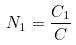Convert formula to latex. <formula><loc_0><loc_0><loc_500><loc_500>N _ { 1 } = \frac { C _ { 1 } } { C }</formula> 